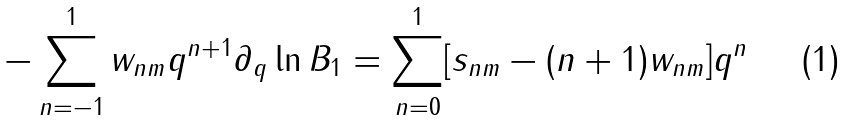Convert formula to latex. <formula><loc_0><loc_0><loc_500><loc_500>- \sum _ { n = - 1 } ^ { 1 } w _ { n m } q ^ { n + 1 } \partial _ { q } \ln B _ { 1 } = \sum _ { n = 0 } ^ { 1 } [ s _ { n m } - ( n + 1 ) w _ { n m } ] q ^ { n }</formula> 